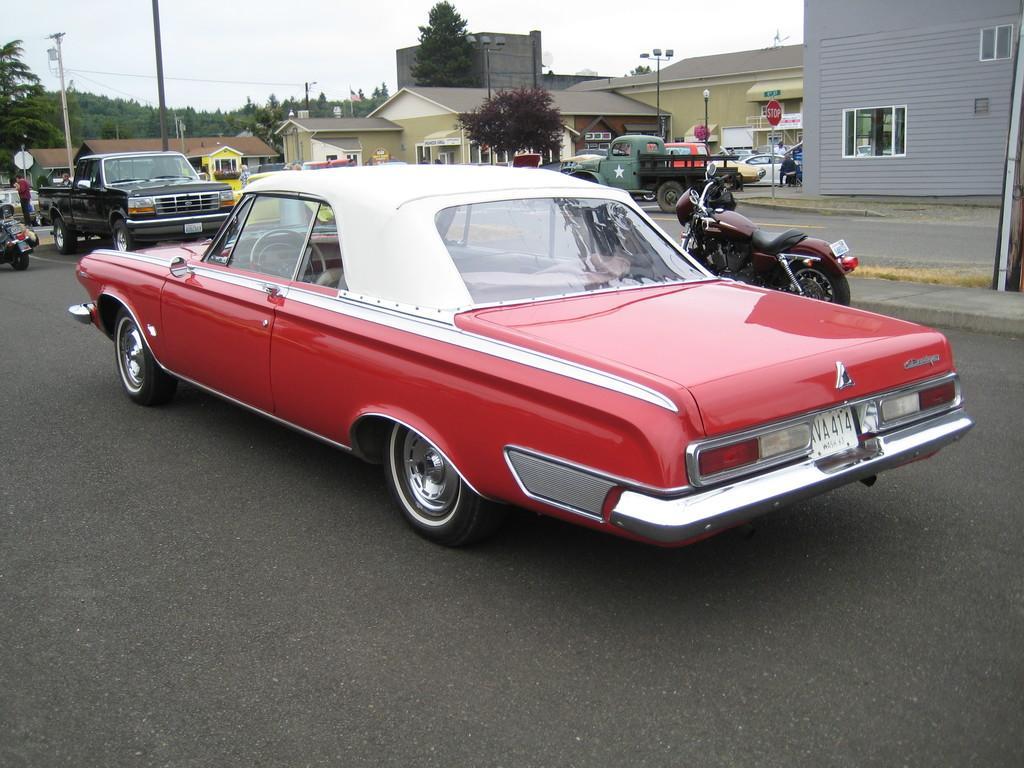How would you summarize this image in a sentence or two? There is a red color car on the road and there are few other vehicles in front and beside it and there are buildings in the right corner and there are trees in the background. 